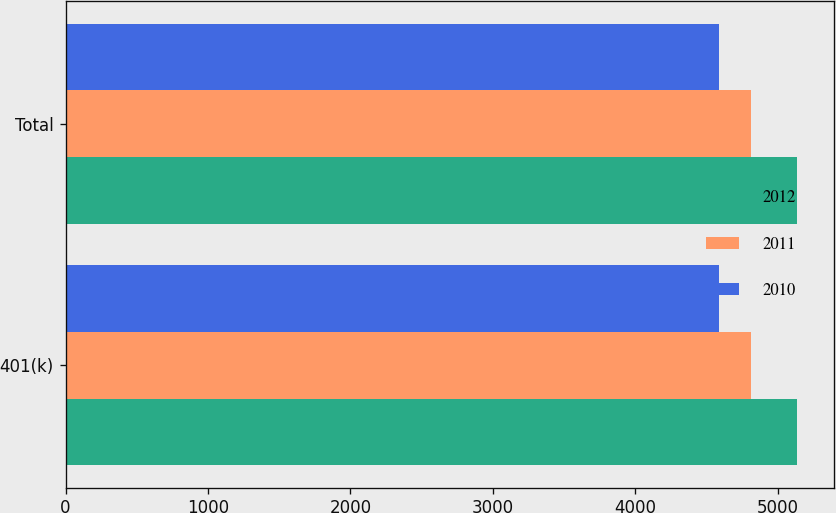<chart> <loc_0><loc_0><loc_500><loc_500><stacked_bar_chart><ecel><fcel>401(k)<fcel>Total<nl><fcel>2012<fcel>5138<fcel>5138<nl><fcel>2011<fcel>4813<fcel>4813<nl><fcel>2010<fcel>4586<fcel>4586<nl></chart> 